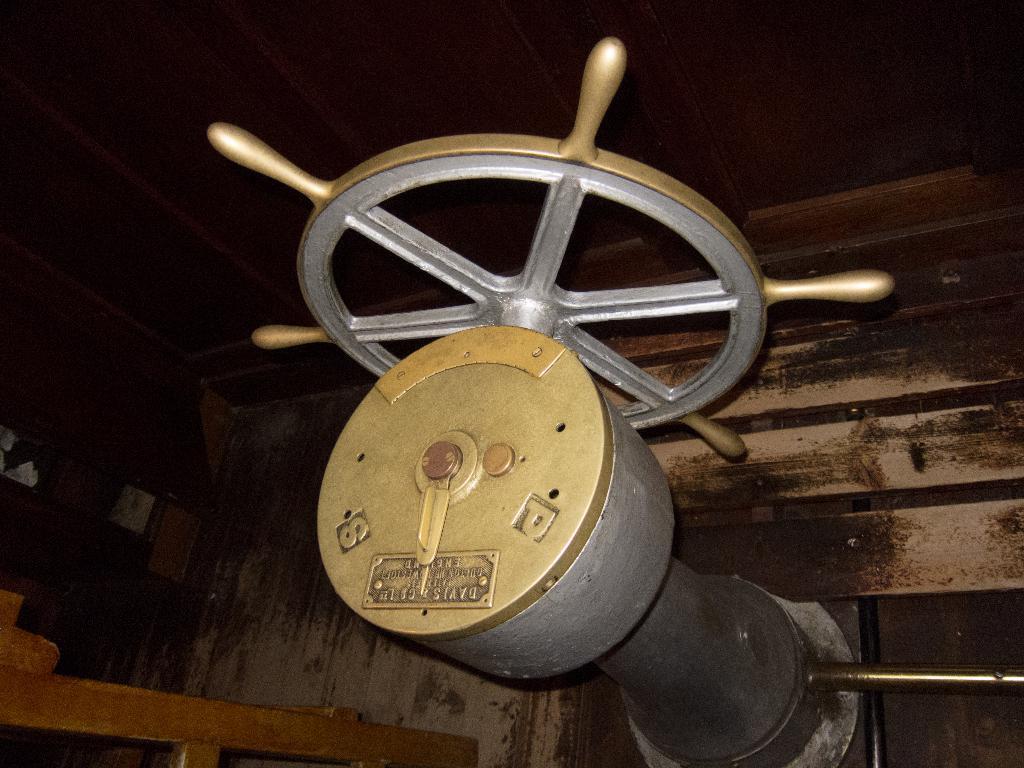How would you summarize this image in a sentence or two? In this image, there is a ship steering wheel. 